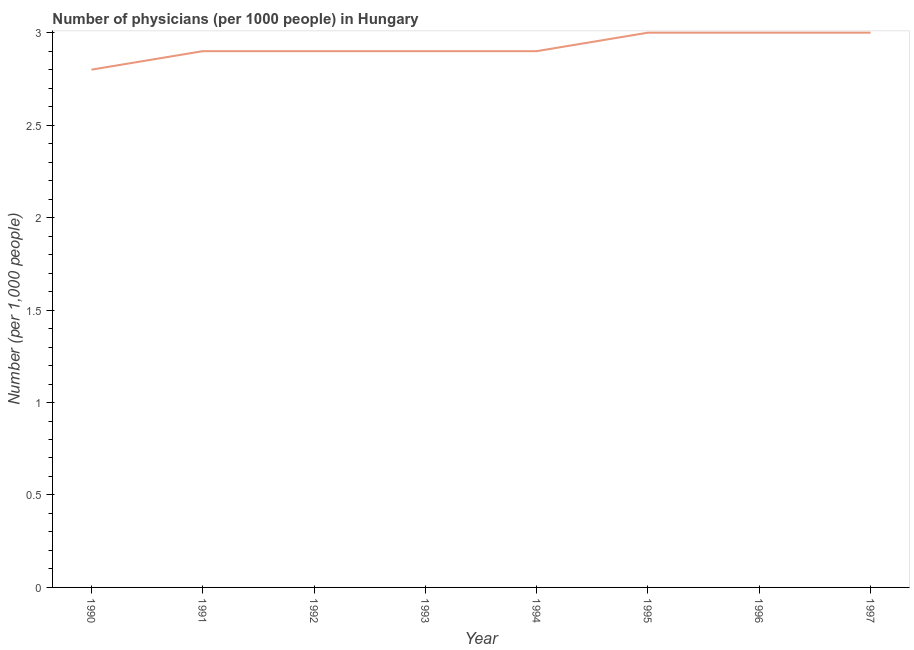What is the number of physicians in 1997?
Offer a terse response. 3. What is the sum of the number of physicians?
Your response must be concise. 23.4. What is the difference between the number of physicians in 1991 and 1995?
Offer a very short reply. -0.1. What is the average number of physicians per year?
Give a very brief answer. 2.92. What is the median number of physicians?
Provide a short and direct response. 2.9. Do a majority of the years between 1990 and 1995 (inclusive) have number of physicians greater than 2.4 ?
Offer a very short reply. Yes. What is the ratio of the number of physicians in 1993 to that in 1994?
Provide a succinct answer. 1. Is the difference between the number of physicians in 1993 and 1996 greater than the difference between any two years?
Keep it short and to the point. No. Is the sum of the number of physicians in 1992 and 1995 greater than the maximum number of physicians across all years?
Your answer should be compact. Yes. What is the difference between the highest and the lowest number of physicians?
Your response must be concise. 0.2. In how many years, is the number of physicians greater than the average number of physicians taken over all years?
Your answer should be very brief. 3. How many lines are there?
Make the answer very short. 1. What is the difference between two consecutive major ticks on the Y-axis?
Your response must be concise. 0.5. Does the graph contain any zero values?
Provide a succinct answer. No. Does the graph contain grids?
Your answer should be very brief. No. What is the title of the graph?
Ensure brevity in your answer.  Number of physicians (per 1000 people) in Hungary. What is the label or title of the X-axis?
Provide a short and direct response. Year. What is the label or title of the Y-axis?
Give a very brief answer. Number (per 1,0 people). What is the Number (per 1,000 people) in 1990?
Your response must be concise. 2.8. What is the Number (per 1,000 people) of 1991?
Ensure brevity in your answer.  2.9. What is the Number (per 1,000 people) of 1992?
Give a very brief answer. 2.9. What is the Number (per 1,000 people) in 1993?
Your answer should be very brief. 2.9. What is the Number (per 1,000 people) in 1994?
Offer a terse response. 2.9. What is the Number (per 1,000 people) in 1995?
Provide a succinct answer. 3. What is the Number (per 1,000 people) of 1996?
Keep it short and to the point. 3. What is the Number (per 1,000 people) in 1997?
Ensure brevity in your answer.  3. What is the difference between the Number (per 1,000 people) in 1990 and 1995?
Give a very brief answer. -0.2. What is the difference between the Number (per 1,000 people) in 1990 and 1996?
Ensure brevity in your answer.  -0.2. What is the difference between the Number (per 1,000 people) in 1990 and 1997?
Provide a short and direct response. -0.2. What is the difference between the Number (per 1,000 people) in 1991 and 1993?
Your response must be concise. 0. What is the difference between the Number (per 1,000 people) in 1991 and 1995?
Provide a succinct answer. -0.1. What is the difference between the Number (per 1,000 people) in 1991 and 1996?
Your response must be concise. -0.1. What is the difference between the Number (per 1,000 people) in 1992 and 1995?
Your answer should be compact. -0.1. What is the difference between the Number (per 1,000 people) in 1992 and 1997?
Offer a very short reply. -0.1. What is the difference between the Number (per 1,000 people) in 1993 and 1995?
Ensure brevity in your answer.  -0.1. What is the difference between the Number (per 1,000 people) in 1993 and 1997?
Ensure brevity in your answer.  -0.1. What is the difference between the Number (per 1,000 people) in 1994 and 1995?
Your answer should be very brief. -0.1. What is the difference between the Number (per 1,000 people) in 1995 and 1997?
Keep it short and to the point. 0. What is the ratio of the Number (per 1,000 people) in 1990 to that in 1991?
Your response must be concise. 0.97. What is the ratio of the Number (per 1,000 people) in 1990 to that in 1993?
Ensure brevity in your answer.  0.97. What is the ratio of the Number (per 1,000 people) in 1990 to that in 1995?
Offer a very short reply. 0.93. What is the ratio of the Number (per 1,000 people) in 1990 to that in 1996?
Keep it short and to the point. 0.93. What is the ratio of the Number (per 1,000 people) in 1990 to that in 1997?
Your response must be concise. 0.93. What is the ratio of the Number (per 1,000 people) in 1991 to that in 1992?
Offer a very short reply. 1. What is the ratio of the Number (per 1,000 people) in 1991 to that in 1993?
Your answer should be compact. 1. What is the ratio of the Number (per 1,000 people) in 1991 to that in 1994?
Offer a very short reply. 1. What is the ratio of the Number (per 1,000 people) in 1992 to that in 1997?
Give a very brief answer. 0.97. What is the ratio of the Number (per 1,000 people) in 1993 to that in 1996?
Provide a short and direct response. 0.97. What is the ratio of the Number (per 1,000 people) in 1994 to that in 1996?
Provide a succinct answer. 0.97. What is the ratio of the Number (per 1,000 people) in 1994 to that in 1997?
Provide a succinct answer. 0.97. What is the ratio of the Number (per 1,000 people) in 1995 to that in 1997?
Make the answer very short. 1. What is the ratio of the Number (per 1,000 people) in 1996 to that in 1997?
Provide a short and direct response. 1. 